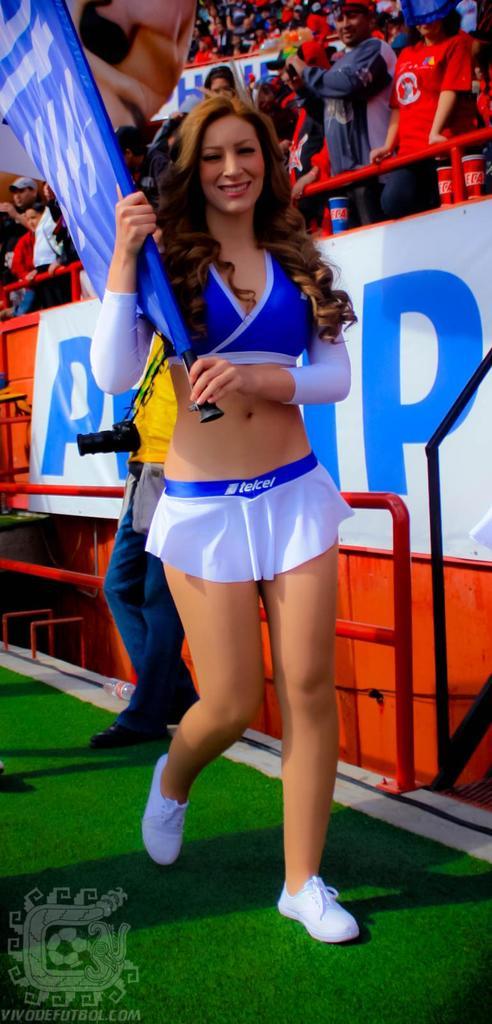What letter is on the right of the lady?
Your response must be concise. P. What is written on the waistband of the lady's skirt?
Provide a short and direct response. Telcel. 